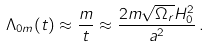Convert formula to latex. <formula><loc_0><loc_0><loc_500><loc_500>\Lambda _ { 0 m } ( t ) \approx \frac { m } { t } \approx \frac { 2 m \sqrt { \Omega _ { r } } H ^ { 2 } _ { 0 } } { a ^ { 2 } } \, .</formula> 